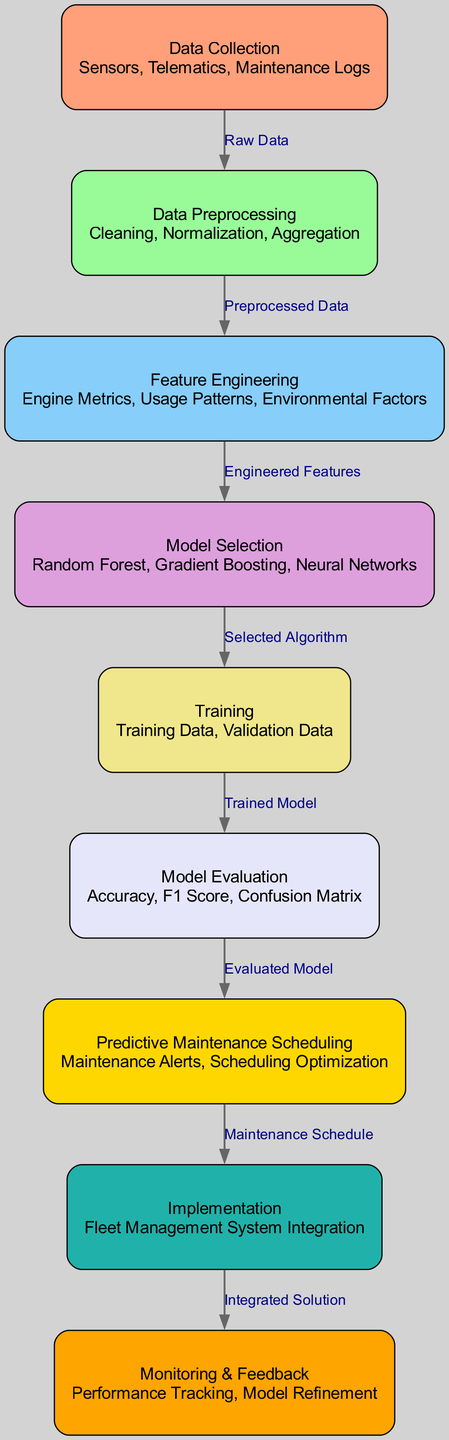What is the first step in the predictive maintenance process? The first step is "Data Collection" as indicated by the top node in the diagram.
Answer: Data Collection How many nodes are present in the diagram? Counting all the unique blocks in the diagram, there are a total of nine nodes.
Answer: Nine What is the output of the "Model Selection" stage? The output of the "Model Selection" stage is "Selected Algorithm," which indicates the algorithm that will be used in the next steps.
Answer: Selected Algorithm What relationship exists between "Model Evaluation" and "Predictive Maintenance Scheduling"? The relationship is that "Model Evaluation" produces the "Evaluated Model," which then feeds into "Predictive Maintenance Scheduling."
Answer: Evaluated Model Which node comes after "Feature Engineering" in the diagram? The node that follows "Feature Engineering" is "Model Selection." This shows the flow from preparing features to selecting a model.
Answer: Model Selection Which algorithms are mentioned in the "Model Selection" node? The algorithms listed in the "Model Selection" node include Random Forest, Gradient Boosting, and Neural Networks, representing various approaches to building the predictive model.
Answer: Random Forest, Gradient Boosting, Neural Networks What does the "Implementation" node lead to in the diagram? The "Implementation" node leads to "Monitoring & Feedback," indicating that after integrating the solution into the fleet management system, monitoring will occur.
Answer: Monitoring & Feedback Explain the flow from "Training" to "Model Evaluation". The flow from "Training" involves taking the "Trained Model," which is derived from the "Training Data" and "Validation Data," and then evaluating its performance, leading to the "Model Evaluation" stage.
Answer: Evaluated Model What is the final output of the predictive maintenance process depicted in the diagram? The final output after all preceding steps culminates in "Monitoring & Feedback," which indicates ongoing tracking and improvement of the predictive maintenance schedule.
Answer: Monitoring & Feedback 